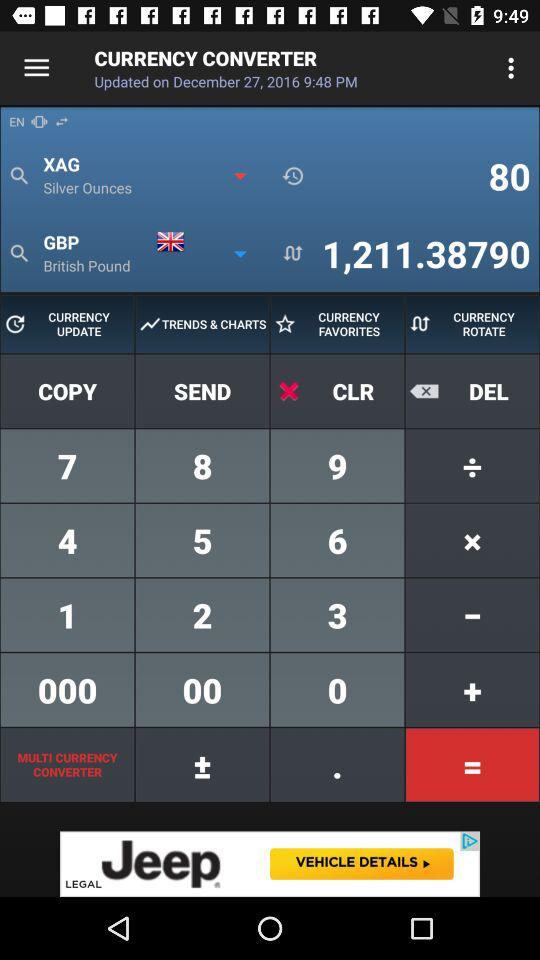Which version of the application is being used?
When the provided information is insufficient, respond with <no answer>. <no answer> 